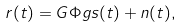<formula> <loc_0><loc_0><loc_500><loc_500>r ( t ) = G \Phi g s ( t ) + n ( t ) ,</formula> 